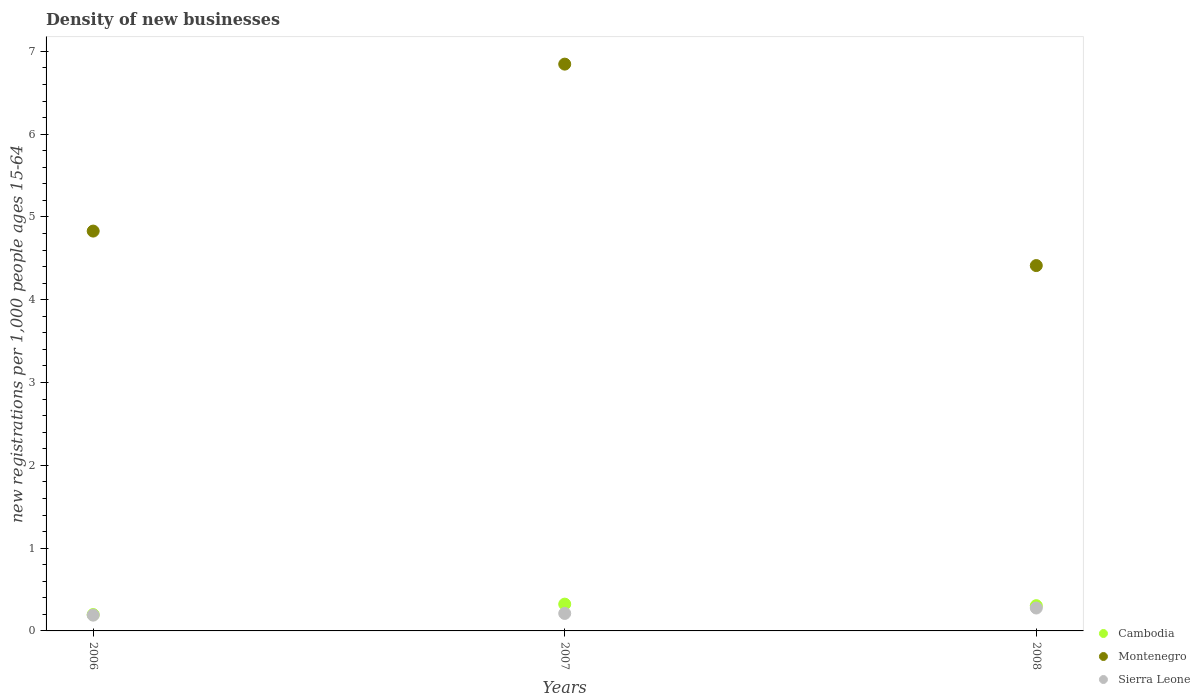Is the number of dotlines equal to the number of legend labels?
Make the answer very short. Yes. What is the number of new registrations in Cambodia in 2007?
Provide a succinct answer. 0.32. Across all years, what is the maximum number of new registrations in Cambodia?
Give a very brief answer. 0.32. Across all years, what is the minimum number of new registrations in Montenegro?
Offer a terse response. 4.41. What is the total number of new registrations in Sierra Leone in the graph?
Provide a succinct answer. 0.68. What is the difference between the number of new registrations in Cambodia in 2007 and that in 2008?
Make the answer very short. 0.02. What is the difference between the number of new registrations in Montenegro in 2006 and the number of new registrations in Cambodia in 2007?
Your answer should be very brief. 4.51. What is the average number of new registrations in Montenegro per year?
Give a very brief answer. 5.36. In the year 2008, what is the difference between the number of new registrations in Cambodia and number of new registrations in Montenegro?
Offer a terse response. -4.11. In how many years, is the number of new registrations in Sierra Leone greater than 5.8?
Your answer should be compact. 0. What is the ratio of the number of new registrations in Cambodia in 2007 to that in 2008?
Give a very brief answer. 1.06. Is the difference between the number of new registrations in Cambodia in 2006 and 2007 greater than the difference between the number of new registrations in Montenegro in 2006 and 2007?
Ensure brevity in your answer.  Yes. What is the difference between the highest and the second highest number of new registrations in Montenegro?
Provide a short and direct response. 2.02. What is the difference between the highest and the lowest number of new registrations in Sierra Leone?
Your answer should be very brief. 0.09. In how many years, is the number of new registrations in Cambodia greater than the average number of new registrations in Cambodia taken over all years?
Provide a succinct answer. 2. Is the sum of the number of new registrations in Montenegro in 2007 and 2008 greater than the maximum number of new registrations in Sierra Leone across all years?
Your answer should be compact. Yes. Is it the case that in every year, the sum of the number of new registrations in Sierra Leone and number of new registrations in Cambodia  is greater than the number of new registrations in Montenegro?
Offer a very short reply. No. Does the number of new registrations in Sierra Leone monotonically increase over the years?
Make the answer very short. Yes. Is the number of new registrations in Sierra Leone strictly greater than the number of new registrations in Cambodia over the years?
Your answer should be very brief. No. How many dotlines are there?
Make the answer very short. 3. How many years are there in the graph?
Keep it short and to the point. 3. What is the difference between two consecutive major ticks on the Y-axis?
Your response must be concise. 1. Are the values on the major ticks of Y-axis written in scientific E-notation?
Offer a very short reply. No. Where does the legend appear in the graph?
Ensure brevity in your answer.  Bottom right. How many legend labels are there?
Give a very brief answer. 3. How are the legend labels stacked?
Your answer should be very brief. Vertical. What is the title of the graph?
Provide a succinct answer. Density of new businesses. Does "Congo (Democratic)" appear as one of the legend labels in the graph?
Make the answer very short. No. What is the label or title of the X-axis?
Provide a succinct answer. Years. What is the label or title of the Y-axis?
Provide a succinct answer. New registrations per 1,0 people ages 15-64. What is the new registrations per 1,000 people ages 15-64 in Cambodia in 2006?
Offer a very short reply. 0.2. What is the new registrations per 1,000 people ages 15-64 in Montenegro in 2006?
Give a very brief answer. 4.83. What is the new registrations per 1,000 people ages 15-64 of Sierra Leone in 2006?
Give a very brief answer. 0.19. What is the new registrations per 1,000 people ages 15-64 of Cambodia in 2007?
Offer a terse response. 0.32. What is the new registrations per 1,000 people ages 15-64 in Montenegro in 2007?
Offer a terse response. 6.85. What is the new registrations per 1,000 people ages 15-64 of Sierra Leone in 2007?
Keep it short and to the point. 0.21. What is the new registrations per 1,000 people ages 15-64 in Cambodia in 2008?
Provide a succinct answer. 0.3. What is the new registrations per 1,000 people ages 15-64 of Montenegro in 2008?
Make the answer very short. 4.41. What is the new registrations per 1,000 people ages 15-64 in Sierra Leone in 2008?
Your response must be concise. 0.28. Across all years, what is the maximum new registrations per 1,000 people ages 15-64 in Cambodia?
Your answer should be compact. 0.32. Across all years, what is the maximum new registrations per 1,000 people ages 15-64 in Montenegro?
Provide a succinct answer. 6.85. Across all years, what is the maximum new registrations per 1,000 people ages 15-64 of Sierra Leone?
Make the answer very short. 0.28. Across all years, what is the minimum new registrations per 1,000 people ages 15-64 in Cambodia?
Give a very brief answer. 0.2. Across all years, what is the minimum new registrations per 1,000 people ages 15-64 in Montenegro?
Your response must be concise. 4.41. Across all years, what is the minimum new registrations per 1,000 people ages 15-64 of Sierra Leone?
Offer a terse response. 0.19. What is the total new registrations per 1,000 people ages 15-64 of Cambodia in the graph?
Your answer should be very brief. 0.83. What is the total new registrations per 1,000 people ages 15-64 in Montenegro in the graph?
Keep it short and to the point. 16.09. What is the total new registrations per 1,000 people ages 15-64 of Sierra Leone in the graph?
Ensure brevity in your answer.  0.68. What is the difference between the new registrations per 1,000 people ages 15-64 in Cambodia in 2006 and that in 2007?
Give a very brief answer. -0.13. What is the difference between the new registrations per 1,000 people ages 15-64 of Montenegro in 2006 and that in 2007?
Your response must be concise. -2.02. What is the difference between the new registrations per 1,000 people ages 15-64 in Sierra Leone in 2006 and that in 2007?
Your answer should be compact. -0.02. What is the difference between the new registrations per 1,000 people ages 15-64 in Cambodia in 2006 and that in 2008?
Your answer should be very brief. -0.11. What is the difference between the new registrations per 1,000 people ages 15-64 of Montenegro in 2006 and that in 2008?
Offer a very short reply. 0.42. What is the difference between the new registrations per 1,000 people ages 15-64 of Sierra Leone in 2006 and that in 2008?
Offer a very short reply. -0.09. What is the difference between the new registrations per 1,000 people ages 15-64 in Cambodia in 2007 and that in 2008?
Your response must be concise. 0.02. What is the difference between the new registrations per 1,000 people ages 15-64 of Montenegro in 2007 and that in 2008?
Offer a very short reply. 2.43. What is the difference between the new registrations per 1,000 people ages 15-64 in Sierra Leone in 2007 and that in 2008?
Your answer should be compact. -0.07. What is the difference between the new registrations per 1,000 people ages 15-64 in Cambodia in 2006 and the new registrations per 1,000 people ages 15-64 in Montenegro in 2007?
Make the answer very short. -6.65. What is the difference between the new registrations per 1,000 people ages 15-64 of Cambodia in 2006 and the new registrations per 1,000 people ages 15-64 of Sierra Leone in 2007?
Make the answer very short. -0.01. What is the difference between the new registrations per 1,000 people ages 15-64 of Montenegro in 2006 and the new registrations per 1,000 people ages 15-64 of Sierra Leone in 2007?
Offer a very short reply. 4.62. What is the difference between the new registrations per 1,000 people ages 15-64 of Cambodia in 2006 and the new registrations per 1,000 people ages 15-64 of Montenegro in 2008?
Ensure brevity in your answer.  -4.22. What is the difference between the new registrations per 1,000 people ages 15-64 in Cambodia in 2006 and the new registrations per 1,000 people ages 15-64 in Sierra Leone in 2008?
Make the answer very short. -0.08. What is the difference between the new registrations per 1,000 people ages 15-64 of Montenegro in 2006 and the new registrations per 1,000 people ages 15-64 of Sierra Leone in 2008?
Your answer should be compact. 4.55. What is the difference between the new registrations per 1,000 people ages 15-64 in Cambodia in 2007 and the new registrations per 1,000 people ages 15-64 in Montenegro in 2008?
Give a very brief answer. -4.09. What is the difference between the new registrations per 1,000 people ages 15-64 of Cambodia in 2007 and the new registrations per 1,000 people ages 15-64 of Sierra Leone in 2008?
Your answer should be compact. 0.05. What is the difference between the new registrations per 1,000 people ages 15-64 in Montenegro in 2007 and the new registrations per 1,000 people ages 15-64 in Sierra Leone in 2008?
Make the answer very short. 6.57. What is the average new registrations per 1,000 people ages 15-64 of Cambodia per year?
Your response must be concise. 0.28. What is the average new registrations per 1,000 people ages 15-64 in Montenegro per year?
Offer a terse response. 5.36. What is the average new registrations per 1,000 people ages 15-64 of Sierra Leone per year?
Make the answer very short. 0.23. In the year 2006, what is the difference between the new registrations per 1,000 people ages 15-64 in Cambodia and new registrations per 1,000 people ages 15-64 in Montenegro?
Provide a short and direct response. -4.63. In the year 2006, what is the difference between the new registrations per 1,000 people ages 15-64 in Cambodia and new registrations per 1,000 people ages 15-64 in Sierra Leone?
Your answer should be very brief. 0.01. In the year 2006, what is the difference between the new registrations per 1,000 people ages 15-64 in Montenegro and new registrations per 1,000 people ages 15-64 in Sierra Leone?
Give a very brief answer. 4.64. In the year 2007, what is the difference between the new registrations per 1,000 people ages 15-64 in Cambodia and new registrations per 1,000 people ages 15-64 in Montenegro?
Your answer should be compact. -6.52. In the year 2007, what is the difference between the new registrations per 1,000 people ages 15-64 in Cambodia and new registrations per 1,000 people ages 15-64 in Sierra Leone?
Make the answer very short. 0.11. In the year 2007, what is the difference between the new registrations per 1,000 people ages 15-64 in Montenegro and new registrations per 1,000 people ages 15-64 in Sierra Leone?
Your response must be concise. 6.63. In the year 2008, what is the difference between the new registrations per 1,000 people ages 15-64 in Cambodia and new registrations per 1,000 people ages 15-64 in Montenegro?
Make the answer very short. -4.11. In the year 2008, what is the difference between the new registrations per 1,000 people ages 15-64 of Cambodia and new registrations per 1,000 people ages 15-64 of Sierra Leone?
Keep it short and to the point. 0.03. In the year 2008, what is the difference between the new registrations per 1,000 people ages 15-64 of Montenegro and new registrations per 1,000 people ages 15-64 of Sierra Leone?
Your answer should be compact. 4.14. What is the ratio of the new registrations per 1,000 people ages 15-64 of Cambodia in 2006 to that in 2007?
Provide a short and direct response. 0.61. What is the ratio of the new registrations per 1,000 people ages 15-64 in Montenegro in 2006 to that in 2007?
Your response must be concise. 0.71. What is the ratio of the new registrations per 1,000 people ages 15-64 of Sierra Leone in 2006 to that in 2007?
Offer a terse response. 0.9. What is the ratio of the new registrations per 1,000 people ages 15-64 of Cambodia in 2006 to that in 2008?
Provide a succinct answer. 0.65. What is the ratio of the new registrations per 1,000 people ages 15-64 in Montenegro in 2006 to that in 2008?
Ensure brevity in your answer.  1.09. What is the ratio of the new registrations per 1,000 people ages 15-64 of Sierra Leone in 2006 to that in 2008?
Offer a very short reply. 0.69. What is the ratio of the new registrations per 1,000 people ages 15-64 of Cambodia in 2007 to that in 2008?
Offer a very short reply. 1.06. What is the ratio of the new registrations per 1,000 people ages 15-64 of Montenegro in 2007 to that in 2008?
Offer a terse response. 1.55. What is the ratio of the new registrations per 1,000 people ages 15-64 of Sierra Leone in 2007 to that in 2008?
Offer a very short reply. 0.76. What is the difference between the highest and the second highest new registrations per 1,000 people ages 15-64 of Cambodia?
Offer a very short reply. 0.02. What is the difference between the highest and the second highest new registrations per 1,000 people ages 15-64 of Montenegro?
Your response must be concise. 2.02. What is the difference between the highest and the second highest new registrations per 1,000 people ages 15-64 in Sierra Leone?
Make the answer very short. 0.07. What is the difference between the highest and the lowest new registrations per 1,000 people ages 15-64 in Cambodia?
Your answer should be compact. 0.13. What is the difference between the highest and the lowest new registrations per 1,000 people ages 15-64 in Montenegro?
Make the answer very short. 2.43. What is the difference between the highest and the lowest new registrations per 1,000 people ages 15-64 of Sierra Leone?
Give a very brief answer. 0.09. 